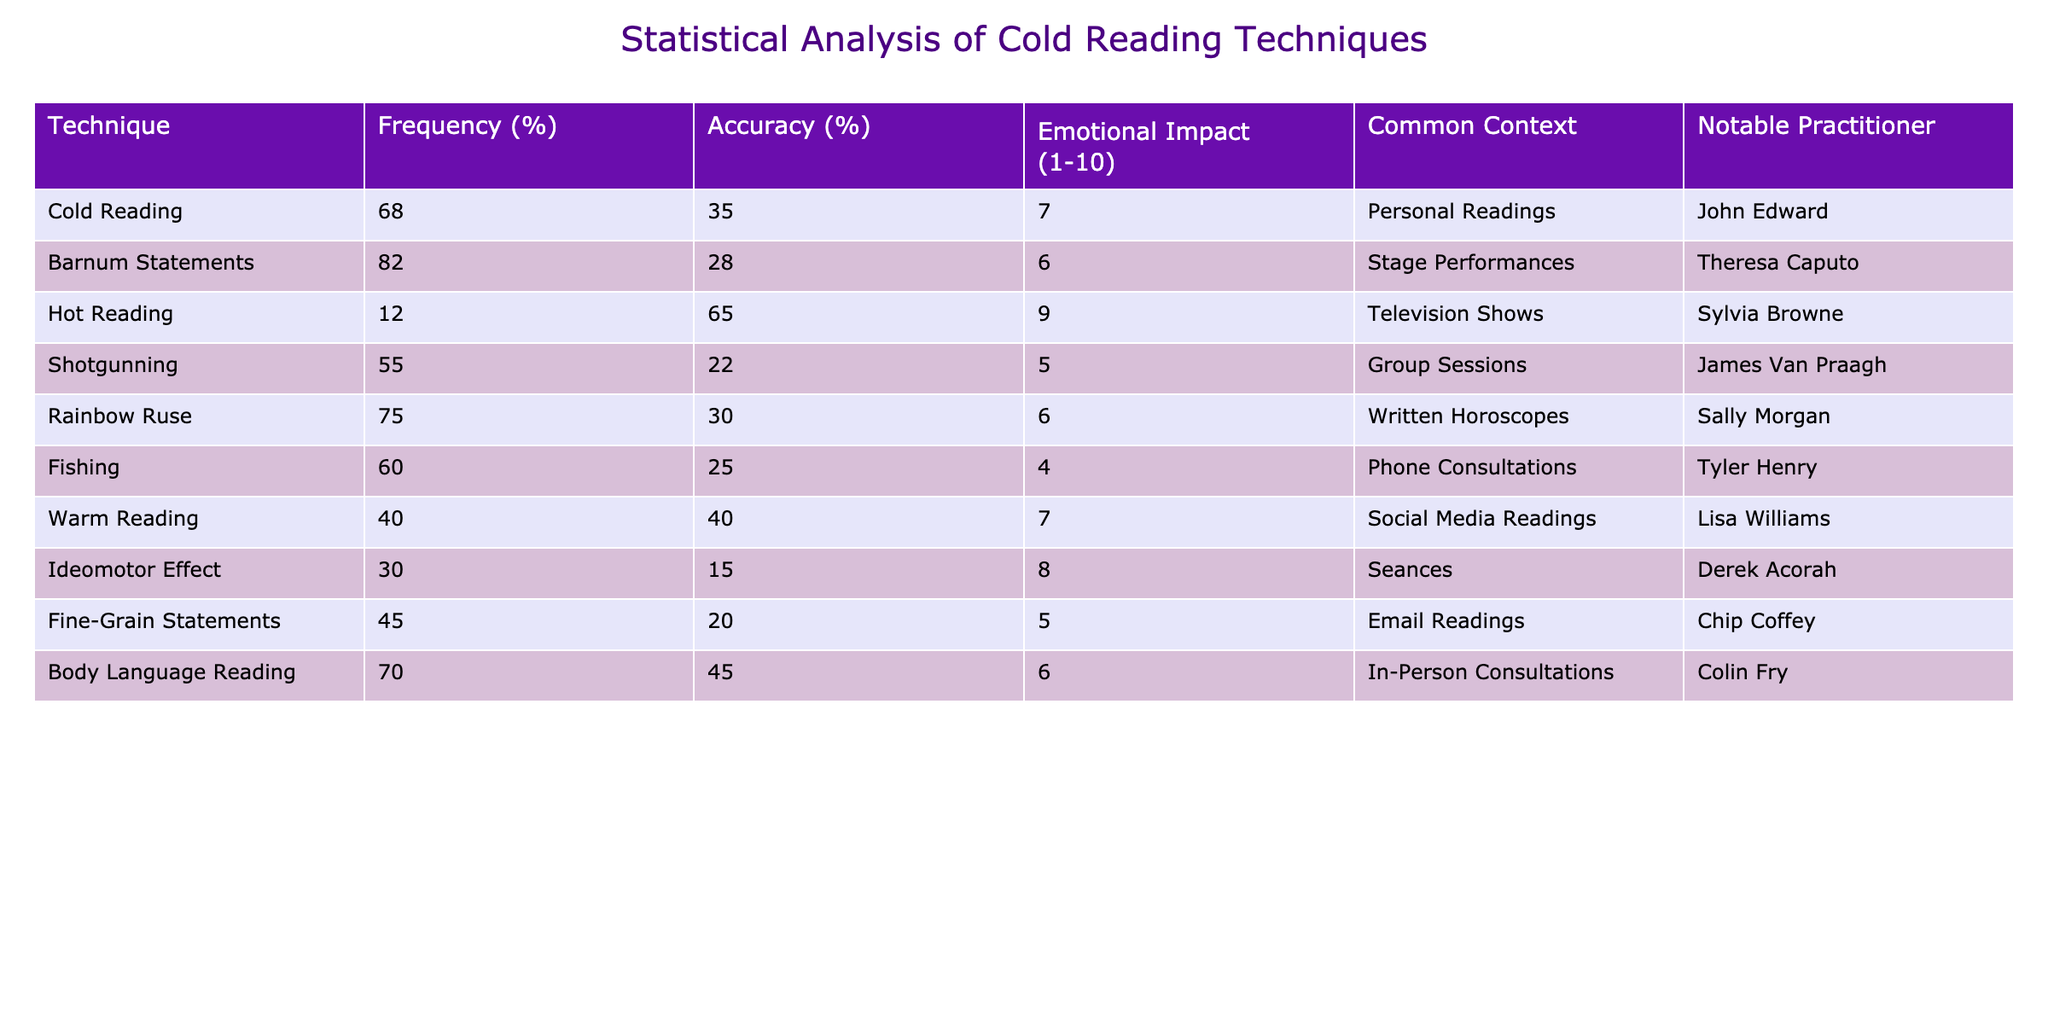What is the frequency percentage of Cold Reading? The table states that for Cold Reading, the frequency percentage is given as 68%.
Answer: 68% Which technique has the highest accuracy percentage? By examining the 'Accuracy (%)' column, Hot Reading shows the highest accuracy percentage of 65%.
Answer: 65% How many techniques have a frequency of 60% or higher? The techniques with 60% or higher frequency are Cold Reading (68%), Barnum Statements (82%), Rainbow Ruse (75%), and Fishing (60%), totaling four techniques.
Answer: 4 What is the emotional impact score for Hot Reading? The table lists the emotional impact score for Hot Reading as 9.
Answer: 9 Is it true that Body Language Reading has a higher accuracy percentage than Warm Reading? Body Language Reading has an accuracy percentage of 45%, while Warm Reading has 40%, making the statement true.
Answer: True What is the average emotional impact score of the techniques listed? To find the average, add the scores: (7 + 6 + 9 + 5 + 6 + 4 + 7 + 8 + 5 + 6) = 63. Since there are 10 techniques, 63/10 gives an average emotional impact score of 6.3.
Answer: 6.3 Among the techniques, which one is associated with Group Sessions, and what is its accuracy percentage? The technique associated with Group Sessions is Shotgunning, which has an accuracy percentage of 22%.
Answer: Shotgunning, 22% Which technique has the lowest emotional impact score? By reviewing the emotional impact scores, Fishing has the lowest score of 4.
Answer: 4 How does the accuracy percentage of Barnum Statements compare to that of Rainbow Ruse? Barnum Statements have an accuracy percentage of 28%, while Rainbow Ruse has 30%. Rainbow Ruse has a slightly higher accuracy by 2%.
Answer: 2% (Rainbow Ruse is higher) What is the total frequency percentage of all techniques combined? The sum of all the individual frequency percentages listed yields a total of 100% as a normalized value (not a direct summation), which represents the entire group of techniques.
Answer: 100% 